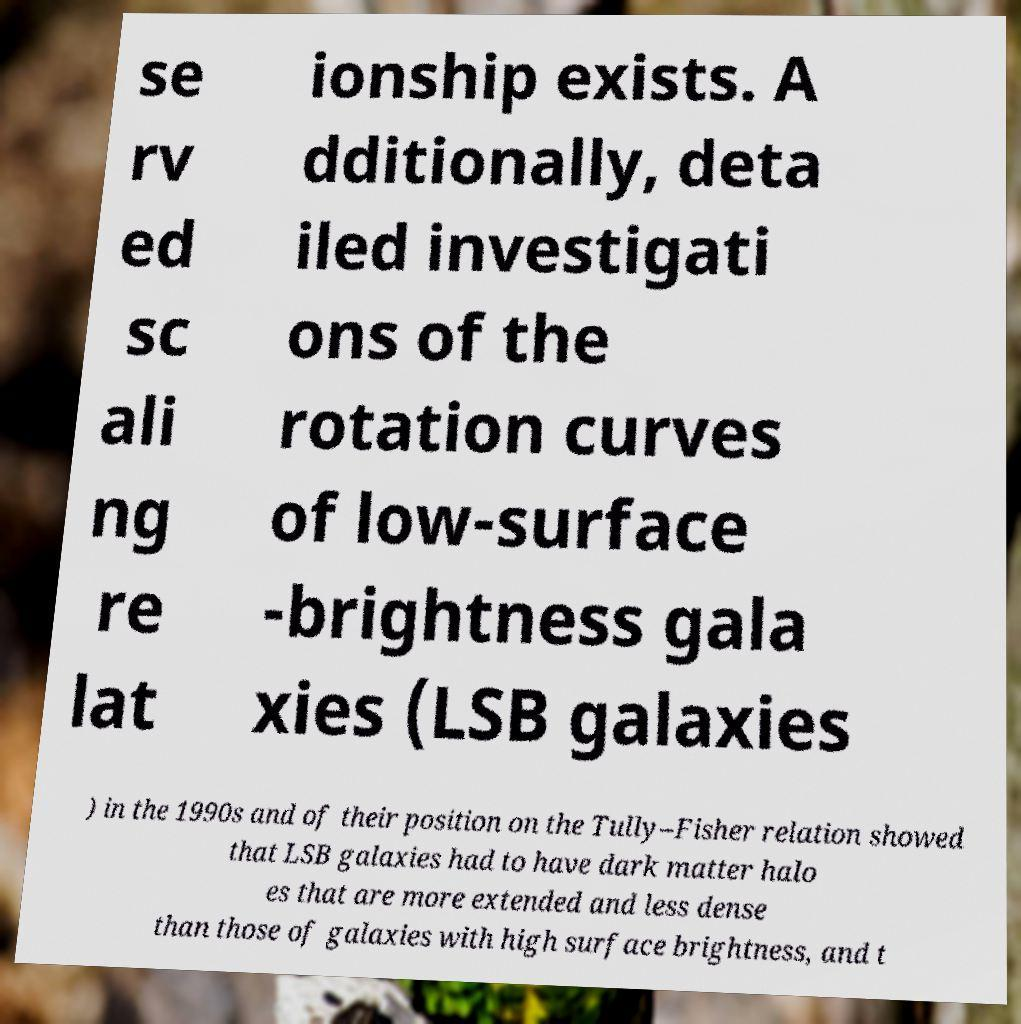I need the written content from this picture converted into text. Can you do that? se rv ed sc ali ng re lat ionship exists. A dditionally, deta iled investigati ons of the rotation curves of low-surface -brightness gala xies (LSB galaxies ) in the 1990s and of their position on the Tully–Fisher relation showed that LSB galaxies had to have dark matter halo es that are more extended and less dense than those of galaxies with high surface brightness, and t 